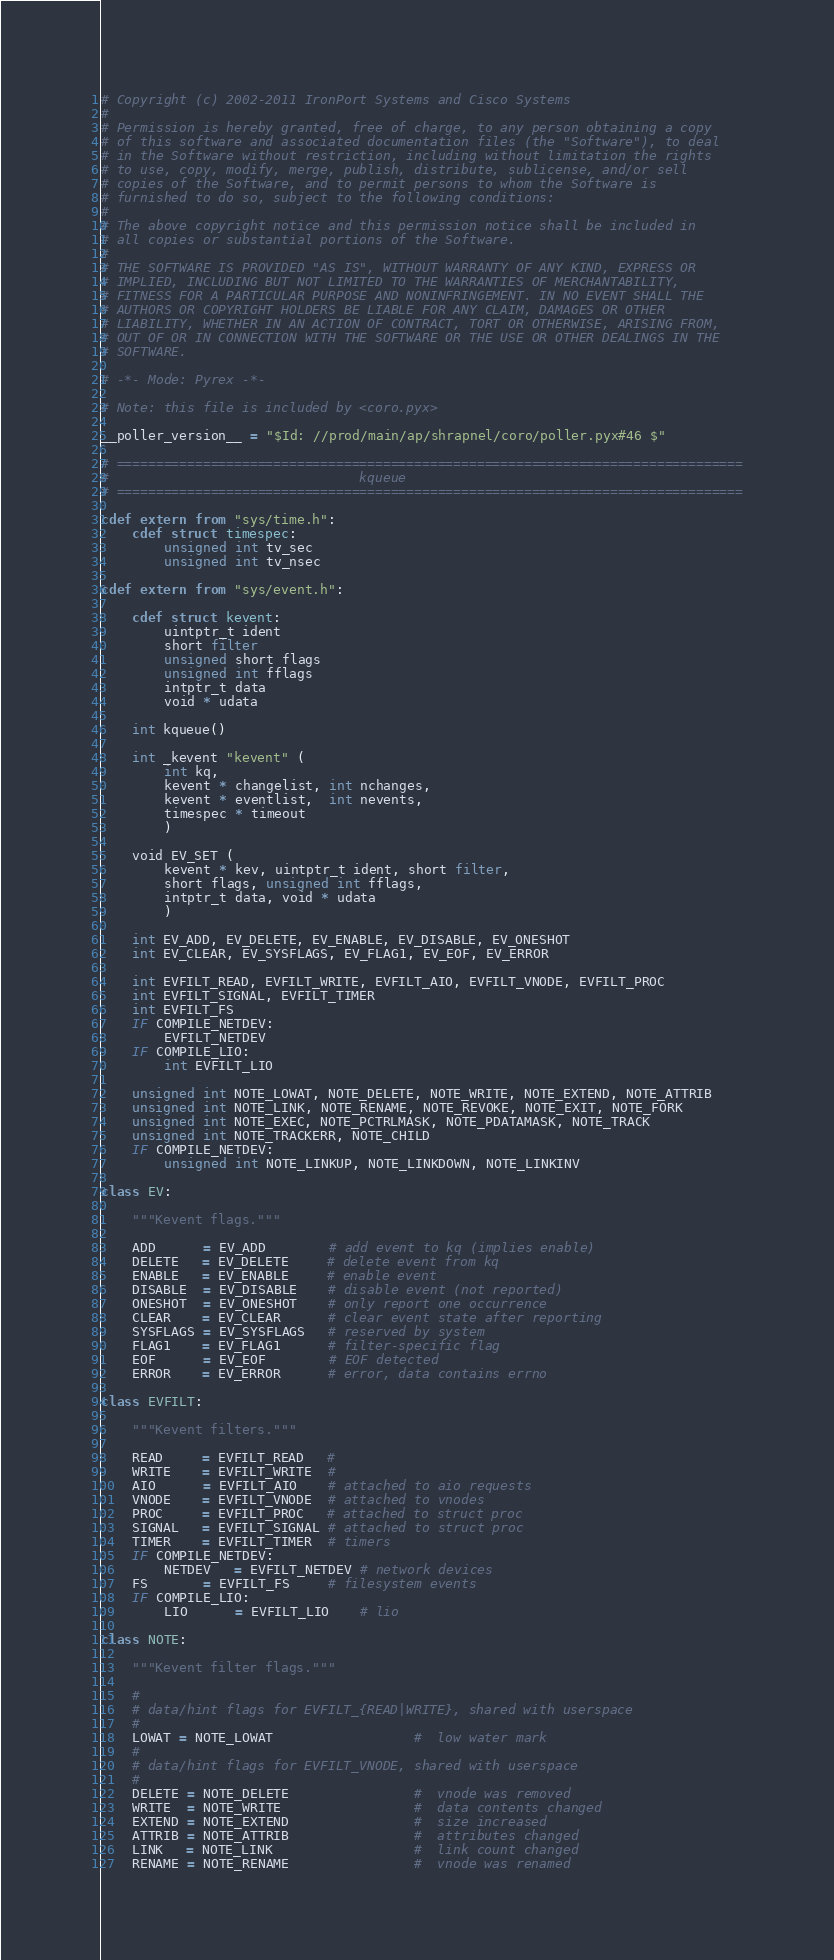Convert code to text. <code><loc_0><loc_0><loc_500><loc_500><_Cython_># Copyright (c) 2002-2011 IronPort Systems and Cisco Systems
# 
# Permission is hereby granted, free of charge, to any person obtaining a copy
# of this software and associated documentation files (the "Software"), to deal
# in the Software without restriction, including without limitation the rights
# to use, copy, modify, merge, publish, distribute, sublicense, and/or sell
# copies of the Software, and to permit persons to whom the Software is
# furnished to do so, subject to the following conditions:
# 
# The above copyright notice and this permission notice shall be included in
# all copies or substantial portions of the Software.
# 
# THE SOFTWARE IS PROVIDED "AS IS", WITHOUT WARRANTY OF ANY KIND, EXPRESS OR
# IMPLIED, INCLUDING BUT NOT LIMITED TO THE WARRANTIES OF MERCHANTABILITY,
# FITNESS FOR A PARTICULAR PURPOSE AND NONINFRINGEMENT. IN NO EVENT SHALL THE
# AUTHORS OR COPYRIGHT HOLDERS BE LIABLE FOR ANY CLAIM, DAMAGES OR OTHER
# LIABILITY, WHETHER IN AN ACTION OF CONTRACT, TORT OR OTHERWISE, ARISING FROM,
# OUT OF OR IN CONNECTION WITH THE SOFTWARE OR THE USE OR OTHER DEALINGS IN THE
# SOFTWARE.

# -*- Mode: Pyrex -*-

# Note: this file is included by <coro.pyx>

__poller_version__ = "$Id: //prod/main/ap/shrapnel/coro/poller.pyx#46 $"

# ================================================================================
#                                kqueue
# ================================================================================

cdef extern from "sys/time.h":
    cdef struct timespec:
        unsigned int tv_sec
        unsigned int tv_nsec

cdef extern from "sys/event.h":

    cdef struct kevent:
        uintptr_t ident
        short filter
        unsigned short flags
        unsigned int fflags
        intptr_t data
        void * udata

    int kqueue()

    int _kevent "kevent" (
        int kq,
        kevent * changelist, int nchanges,
        kevent * eventlist,  int nevents,
        timespec * timeout
        )

    void EV_SET (
        kevent * kev, uintptr_t ident, short filter,
        short flags, unsigned int fflags,
        intptr_t data, void * udata
        )

    int EV_ADD, EV_DELETE, EV_ENABLE, EV_DISABLE, EV_ONESHOT
    int EV_CLEAR, EV_SYSFLAGS, EV_FLAG1, EV_EOF, EV_ERROR

    int EVFILT_READ, EVFILT_WRITE, EVFILT_AIO, EVFILT_VNODE, EVFILT_PROC
    int EVFILT_SIGNAL, EVFILT_TIMER
    int EVFILT_FS
    IF COMPILE_NETDEV:
        EVFILT_NETDEV
    IF COMPILE_LIO:
        int EVFILT_LIO

    unsigned int NOTE_LOWAT, NOTE_DELETE, NOTE_WRITE, NOTE_EXTEND, NOTE_ATTRIB
    unsigned int NOTE_LINK, NOTE_RENAME, NOTE_REVOKE, NOTE_EXIT, NOTE_FORK
    unsigned int NOTE_EXEC, NOTE_PCTRLMASK, NOTE_PDATAMASK, NOTE_TRACK
    unsigned int NOTE_TRACKERR, NOTE_CHILD
    IF COMPILE_NETDEV:
        unsigned int NOTE_LINKUP, NOTE_LINKDOWN, NOTE_LINKINV

class EV:

    """Kevent flags."""

    ADD      = EV_ADD        # add event to kq (implies enable)
    DELETE   = EV_DELETE     # delete event from kq
    ENABLE   = EV_ENABLE     # enable event
    DISABLE  = EV_DISABLE    # disable event (not reported)
    ONESHOT  = EV_ONESHOT    # only report one occurrence
    CLEAR    = EV_CLEAR      # clear event state after reporting
    SYSFLAGS = EV_SYSFLAGS   # reserved by system
    FLAG1    = EV_FLAG1      # filter-specific flag
    EOF      = EV_EOF        # EOF detected
    ERROR    = EV_ERROR      # error, data contains errno

class EVFILT:

    """Kevent filters."""

    READ     = EVFILT_READ   #
    WRITE    = EVFILT_WRITE  #
    AIO      = EVFILT_AIO    # attached to aio requests
    VNODE    = EVFILT_VNODE  # attached to vnodes
    PROC     = EVFILT_PROC   # attached to struct proc
    SIGNAL   = EVFILT_SIGNAL # attached to struct proc
    TIMER    = EVFILT_TIMER  # timers
    IF COMPILE_NETDEV:
        NETDEV   = EVFILT_NETDEV # network devices
    FS       = EVFILT_FS     # filesystem events
    IF COMPILE_LIO:
        LIO      = EVFILT_LIO    # lio

class NOTE:

    """Kevent filter flags."""

    #
    # data/hint flags for EVFILT_{READ|WRITE}, shared with userspace
    #
    LOWAT = NOTE_LOWAT                  #  low water mark
    #
    # data/hint flags for EVFILT_VNODE, shared with userspace
    #
    DELETE = NOTE_DELETE                #  vnode was removed
    WRITE  = NOTE_WRITE                 #  data contents changed
    EXTEND = NOTE_EXTEND                #  size increased
    ATTRIB = NOTE_ATTRIB                #  attributes changed
    LINK   = NOTE_LINK                  #  link count changed
    RENAME = NOTE_RENAME                #  vnode was renamed</code> 